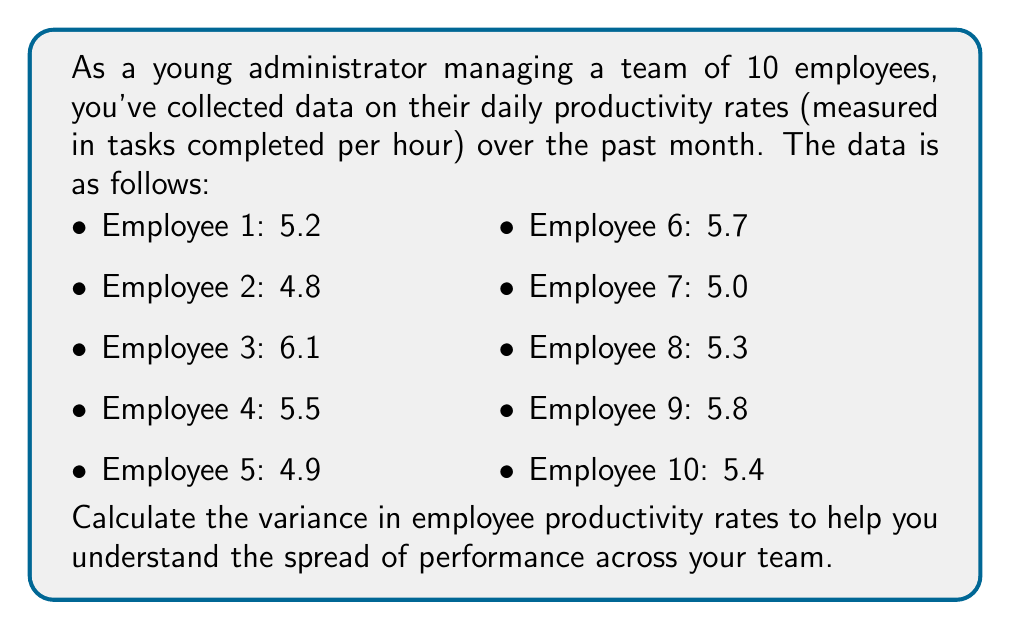Provide a solution to this math problem. To calculate the variance in employee productivity rates, we'll follow these steps:

1. Calculate the mean productivity rate:
   $$\bar{x} = \frac{\sum_{i=1}^{n} x_i}{n}$$
   where $x_i$ are the individual productivity rates and $n$ is the number of employees.

   $$\bar{x} = \frac{5.2 + 4.8 + 6.1 + 5.5 + 4.9 + 5.7 + 5.0 + 5.3 + 5.8 + 5.4}{10} = 5.37$$

2. Calculate the squared differences from the mean:
   $$(x_i - \bar{x})^2$$

   Employee 1: $(5.2 - 5.37)^2 = 0.0289$
   Employee 2: $(4.8 - 5.37)^2 = 0.3249$
   Employee 3: $(6.1 - 5.37)^2 = 0.5329$
   Employee 4: $(5.5 - 5.37)^2 = 0.0169$
   Employee 5: $(4.9 - 5.37)^2 = 0.2209$
   Employee 6: $(5.7 - 5.37)^2 = 0.1089$
   Employee 7: $(5.0 - 5.37)^2 = 0.1369$
   Employee 8: $(5.3 - 5.37)^2 = 0.0049$
   Employee 9: $(5.8 - 5.37)^2 = 0.1849$
   Employee 10: $(5.4 - 5.37)^2 = 0.0009$

3. Sum the squared differences:
   $$\sum_{i=1}^{n} (x_i - \bar{x})^2 = 1.561$$

4. Calculate the variance using the formula:
   $$\sigma^2 = \frac{\sum_{i=1}^{n} (x_i - \bar{x})^2}{n-1}$$

   $$\sigma^2 = \frac{1.561}{9} = 0.1734$$

The variance in employee productivity rates is approximately 0.1734 (tasks/hour)².
Answer: The variance in employee productivity rates is 0.1734 (tasks/hour)². 